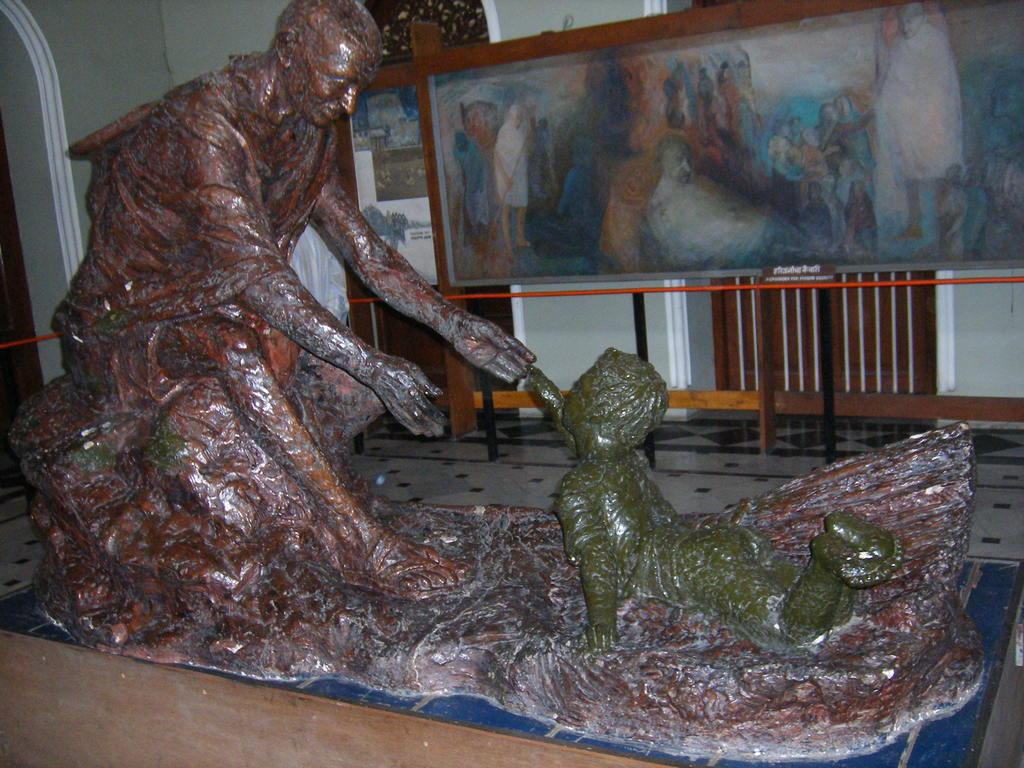What type of objects can be seen in the image? There are statues in the image. What is the color of the wall in the image? There is a white color wall in the image. What else is present in the image besides the statues and wall? There are banners in the image. What type of prose is being recited by the statues in the image? There is no indication in the image that the statues are reciting any prose. Is there a nose visible on any of the statues in the image? The provided facts do not mention any specific details about the statues' features, so it cannot be determined if any of them have a nose. 